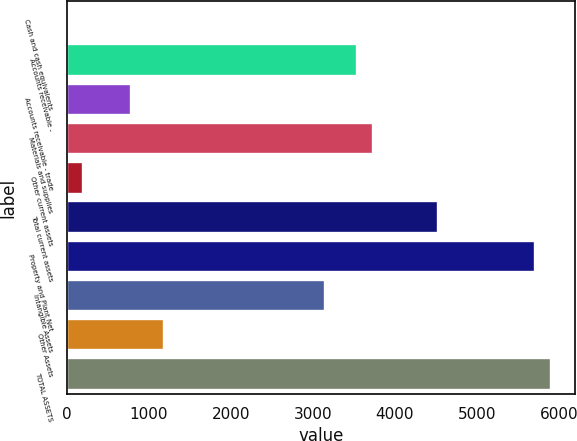Convert chart. <chart><loc_0><loc_0><loc_500><loc_500><bar_chart><fcel>Cash and cash equivalents<fcel>Accounts receivable -<fcel>Accounts receivable - trade<fcel>Materials and supplies<fcel>Other current assets<fcel>Total current assets<fcel>Property and Plant Net<fcel>Intangible Assets<fcel>Other Assets<fcel>TOTAL ASSETS<nl><fcel>2<fcel>3540.8<fcel>788.4<fcel>3737.4<fcel>198.6<fcel>4523.8<fcel>5703.4<fcel>3147.6<fcel>1181.6<fcel>5900<nl></chart> 